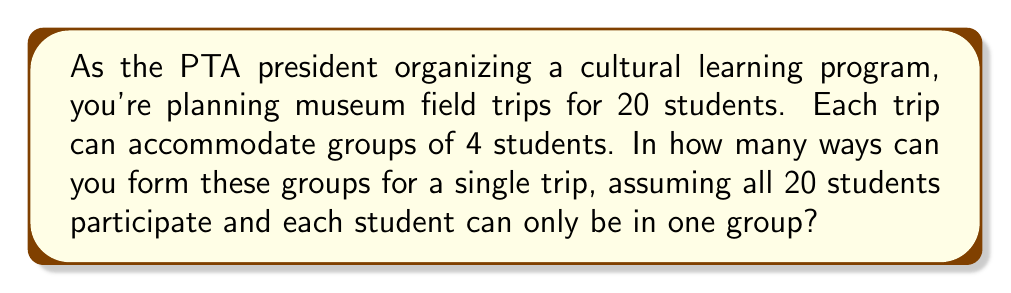Provide a solution to this math problem. Let's approach this step-by-step:

1) This is a partition problem, specifically dividing 20 students into 5 groups of 4 each.

2) We can use the formula for the number of ways to partition n distinct objects into k groups of sizes $n_1, n_2, ..., n_k$:

   $$\frac{n!}{n_1! \cdot n_2! \cdot ... \cdot n_k!}$$

3) In our case:
   - $n = 20$ (total students)
   - $k = 5$ (number of groups)
   - $n_1 = n_2 = n_3 = n_4 = n_5 = 4$ (size of each group)

4) Plugging into the formula:

   $$\frac{20!}{(4!)^5}$$

5) Simplify:
   $$\frac{20!}{(24)^5} = \frac{20!}{7,962,624}$$

6) Calculate:
   $$\frac{2,432,902,008,176,640,000}{7,962,624} = 305,540,235$$

Therefore, there are 305,540,235 ways to form these groups.
Answer: 305,540,235 